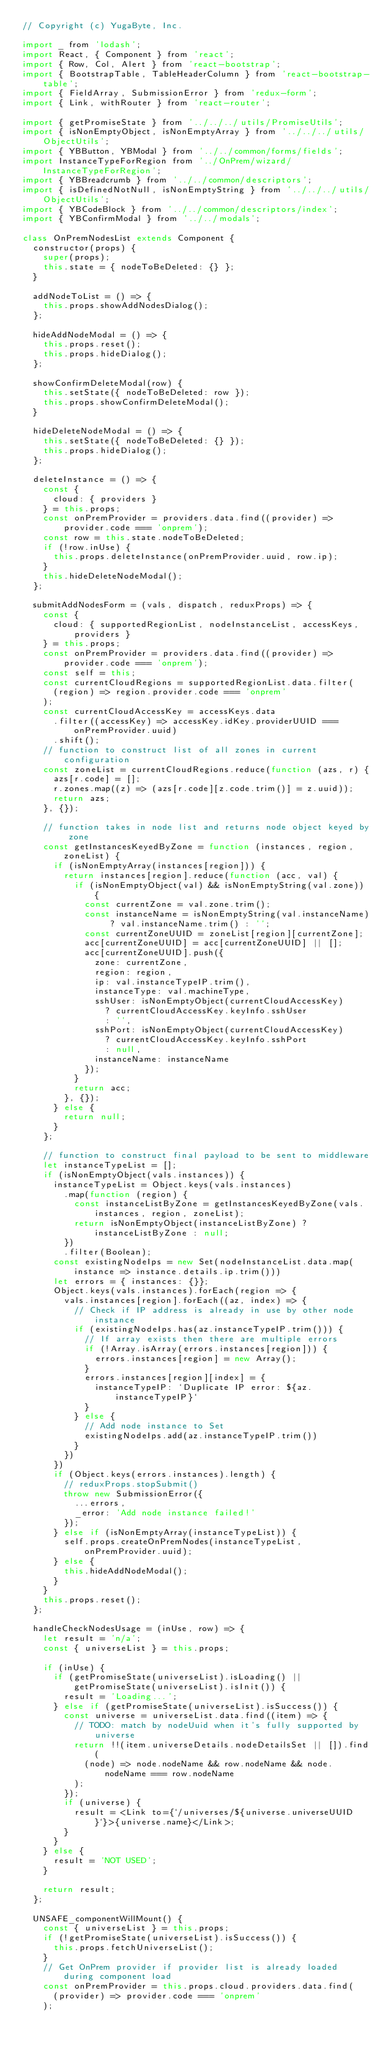<code> <loc_0><loc_0><loc_500><loc_500><_JavaScript_>// Copyright (c) YugaByte, Inc.

import _ from 'lodash';
import React, { Component } from 'react';
import { Row, Col, Alert } from 'react-bootstrap';
import { BootstrapTable, TableHeaderColumn } from 'react-bootstrap-table';
import { FieldArray, SubmissionError } from 'redux-form';
import { Link, withRouter } from 'react-router';

import { getPromiseState } from '../../../utils/PromiseUtils';
import { isNonEmptyObject, isNonEmptyArray } from '../../../utils/ObjectUtils';
import { YBButton, YBModal } from '../../common/forms/fields';
import InstanceTypeForRegion from '../OnPrem/wizard/InstanceTypeForRegion';
import { YBBreadcrumb } from '../../common/descriptors';
import { isDefinedNotNull, isNonEmptyString } from '../../../utils/ObjectUtils';
import { YBCodeBlock } from '../../common/descriptors/index';
import { YBConfirmModal } from '../../modals';

class OnPremNodesList extends Component {
  constructor(props) {
    super(props);
    this.state = { nodeToBeDeleted: {} };
  }

  addNodeToList = () => {
    this.props.showAddNodesDialog();
  };

  hideAddNodeModal = () => {
    this.props.reset();
    this.props.hideDialog();
  };

  showConfirmDeleteModal(row) {
    this.setState({ nodeToBeDeleted: row });
    this.props.showConfirmDeleteModal();
  }

  hideDeleteNodeModal = () => {
    this.setState({ nodeToBeDeleted: {} });
    this.props.hideDialog();
  };

  deleteInstance = () => {
    const {
      cloud: { providers }
    } = this.props;
    const onPremProvider = providers.data.find((provider) => provider.code === 'onprem');
    const row = this.state.nodeToBeDeleted;
    if (!row.inUse) {
      this.props.deleteInstance(onPremProvider.uuid, row.ip);
    }
    this.hideDeleteNodeModal();
  };

  submitAddNodesForm = (vals, dispatch, reduxProps) => {
    const {
      cloud: { supportedRegionList, nodeInstanceList, accessKeys, providers }
    } = this.props;
    const onPremProvider = providers.data.find((provider) => provider.code === 'onprem');
    const self = this;
    const currentCloudRegions = supportedRegionList.data.filter(
      (region) => region.provider.code === 'onprem'
    );    
    const currentCloudAccessKey = accessKeys.data
      .filter((accessKey) => accessKey.idKey.providerUUID === onPremProvider.uuid)
      .shift();
    // function to construct list of all zones in current configuration
    const zoneList = currentCloudRegions.reduce(function (azs, r) {
      azs[r.code] = [];
      r.zones.map((z) => (azs[r.code][z.code.trim()] = z.uuid));
      return azs;
    }, {});

    // function takes in node list and returns node object keyed by zone
    const getInstancesKeyedByZone = function (instances, region, zoneList) {
      if (isNonEmptyArray(instances[region])) {
        return instances[region].reduce(function (acc, val) {
          if (isNonEmptyObject(val) && isNonEmptyString(val.zone)) {
            const currentZone = val.zone.trim();
            const instanceName = isNonEmptyString(val.instanceName) ? val.instanceName.trim() : '';
            const currentZoneUUID = zoneList[region][currentZone];
            acc[currentZoneUUID] = acc[currentZoneUUID] || [];
            acc[currentZoneUUID].push({
              zone: currentZone,
              region: region,
              ip: val.instanceTypeIP.trim(),
              instanceType: val.machineType,
              sshUser: isNonEmptyObject(currentCloudAccessKey)
                ? currentCloudAccessKey.keyInfo.sshUser
                : '',
              sshPort: isNonEmptyObject(currentCloudAccessKey)
                ? currentCloudAccessKey.keyInfo.sshPort
                : null,
              instanceName: instanceName
            });
          }
          return acc;
        }, {});
      } else {
        return null;
      }
    };

    // function to construct final payload to be sent to middleware
    let instanceTypeList = [];
    if (isNonEmptyObject(vals.instances)) {
      instanceTypeList = Object.keys(vals.instances)
        .map(function (region) {
          const instanceListByZone = getInstancesKeyedByZone(vals.instances, region, zoneList);
          return isNonEmptyObject(instanceListByZone) ? instanceListByZone : null;
        })
        .filter(Boolean);
      const existingNodeIps = new Set(nodeInstanceList.data.map(instance => instance.details.ip.trim()))
      let errors = { instances: {}};
      Object.keys(vals.instances).forEach(region => {
        vals.instances[region].forEach((az, index) => {
          // Check if IP address is already in use by other node instance
          if (existingNodeIps.has(az.instanceTypeIP.trim())) {
            // If array exists then there are multiple errors
            if (!Array.isArray(errors.instances[region])) {
              errors.instances[region] = new Array();
            }
            errors.instances[region][index] = {
              instanceTypeIP: `Duplicate IP error: ${az.instanceTypeIP}`
            }
          } else {
            // Add node instance to Set
            existingNodeIps.add(az.instanceTypeIP.trim())
          }
        })
      })
      if (Object.keys(errors.instances).length) {
        // reduxProps.stopSubmit()
        throw new SubmissionError({
          ...errors,
          _error: 'Add node instance failed!'
        });
      } else if (isNonEmptyArray(instanceTypeList)) {
        self.props.createOnPremNodes(instanceTypeList, onPremProvider.uuid);
      } else {
        this.hideAddNodeModal();
      }
    }
    this.props.reset();
  };

  handleCheckNodesUsage = (inUse, row) => {
    let result = 'n/a';
    const { universeList } = this.props;

    if (inUse) {
      if (getPromiseState(universeList).isLoading() || getPromiseState(universeList).isInit()) {
        result = 'Loading...';
      } else if (getPromiseState(universeList).isSuccess()) {
        const universe = universeList.data.find((item) => {
          // TODO: match by nodeUuid when it's fully supported by universe
          return !!(item.universeDetails.nodeDetailsSet || []).find(
            (node) => node.nodeName && row.nodeName && node.nodeName === row.nodeName
          );
        });
        if (universe) {
          result = <Link to={`/universes/${universe.universeUUID}`}>{universe.name}</Link>;
        }
      }
    } else {
      result = 'NOT USED';
    }

    return result;
  };

  UNSAFE_componentWillMount() {
    const { universeList } = this.props;
    if (!getPromiseState(universeList).isSuccess()) {
      this.props.fetchUniverseList();
    }
    // Get OnPrem provider if provider list is already loaded during component load
    const onPremProvider = this.props.cloud.providers.data.find(
      (provider) => provider.code === 'onprem'
    );</code> 